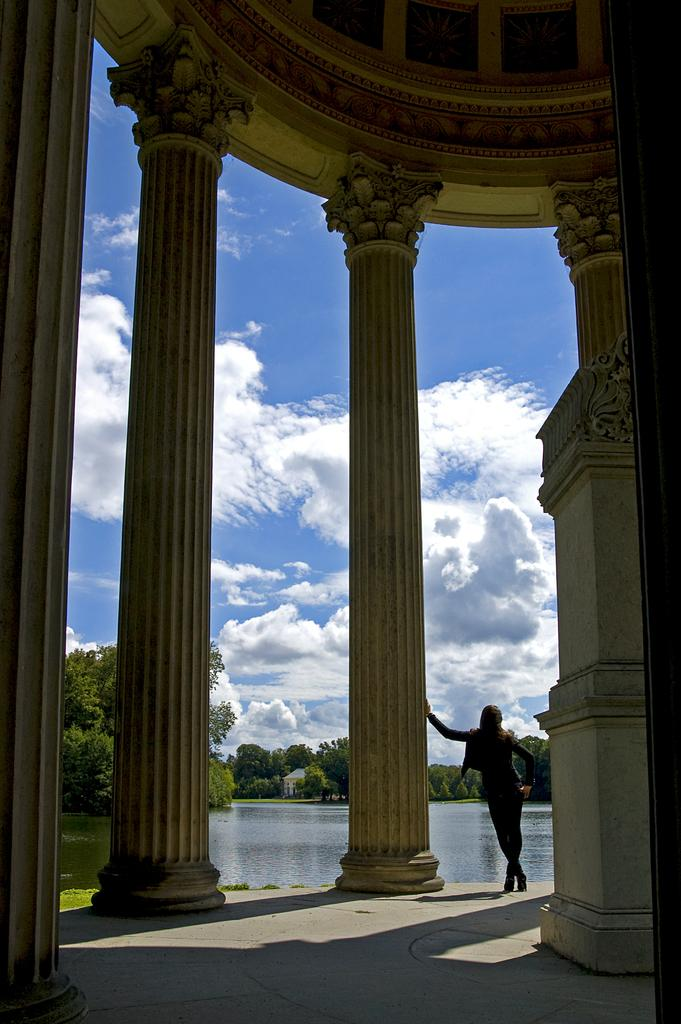What is the main subject in the image? There is a person standing in the image. Can you describe the person's attire? The person is wearing clothes. What can be seen at the bottom of the image? There is a lake at the bottom of the image. What architectural features are present in the image? There are pillars in the image. What is visible in the background of the image? The sky is visible in the image. Are there any ducks swimming in the lake in the image? There is no mention of ducks in the image, so we cannot determine if any are present. 